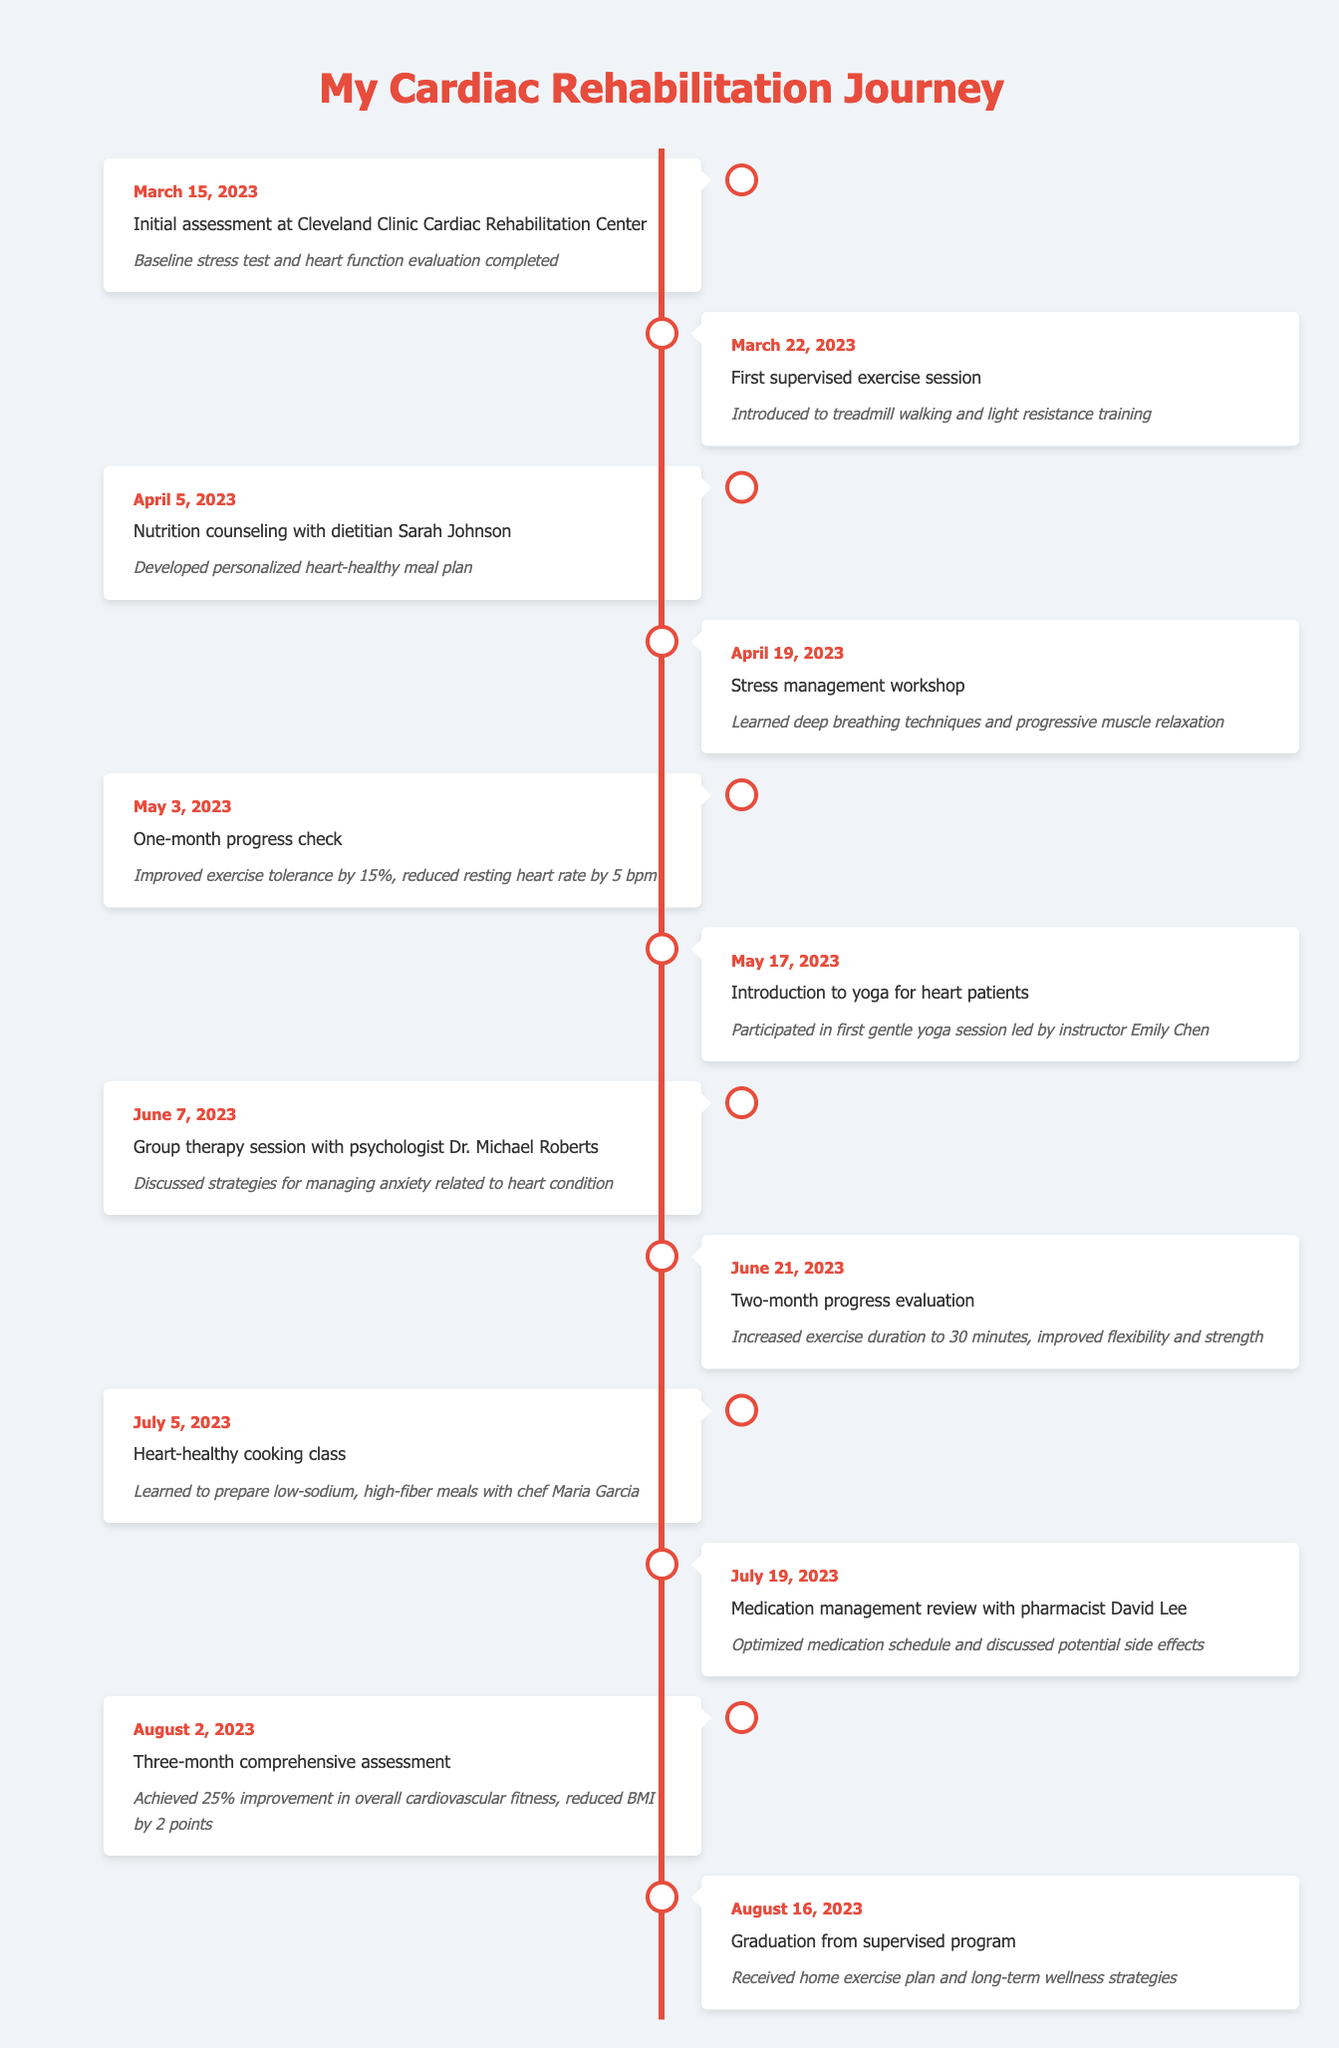What event occurred on March 15, 2023? The table indicates that on March 15, 2023, the event was the "Initial assessment at Cleveland Clinic Cardiac Rehabilitation Center.” This is stated clearly in the timeline.
Answer: Initial assessment at Cleveland Clinic Cardiac Rehabilitation Center How many weeks were between the initial assessment and the first supervised exercise session? The initial assessment was on March 15, 2023, and the first supervised exercise session was on March 22, 2023. This is exactly 1 week apart.
Answer: 1 week Did the patient attend any nutrition counseling sessions? Yes, the table shows a nutrition counseling event on April 5, 2023, indicating that the patient attended a session with dietitian Sarah Johnson. Thus, the answer is yes.
Answer: Yes What was the percentage improvement in exercise tolerance after one month? The one-month progress check on May 3, 2023, indicates an improvement in exercise tolerance by 15%. This fact can be found directly in the details of that event.
Answer: 15% What improvements were observed during the three-month comprehensive assessment? According to the details from the event on August 2, 2023, the comprehensive assessment noted a 25% improvement in overall cardiovascular fitness and a reduction in BMI by 2 points. Therefore, both improvements are cumulatively the answer.
Answer: 25% improvement in cardiovascular fitness, BMI reduced by 2 points How many total events related to emotional well-being management were documented? The timeline includes two events directly related to emotional well-being: the stress management workshop on April 19 and the group therapy session on June 7. Thus, the total number of these events is 2.
Answer: 2 events What is the average time duration of the exercise sessions by the two-month evaluation? The two-month evaluation on June 21, 2023, reports an increased exercise duration to 30 minutes, while the earlier one-month check doesn’t specify an exact duration but indicates improvement. Assuming the improvement was incremental, we'd average the two points considering 15 minutes as a starting hypothesis. Thus, the average could be estimated between them as around 22.5 minutes.
Answer: 22.5 minutes Was there a cooking class that focused on heart-healthy recipes, and when did it occur? Yes, the table notes a heart-healthy cooking class on July 5, 2023, which confirms that this specific event took place.
Answer: Yes, on July 5, 2023 What is the date of the graduation from the supervised program? According to the timeline, the graduation from the supervised program is clearly noted as occurring on August 16, 2023. This is a precise fact stated in the events.
Answer: August 16, 2023 